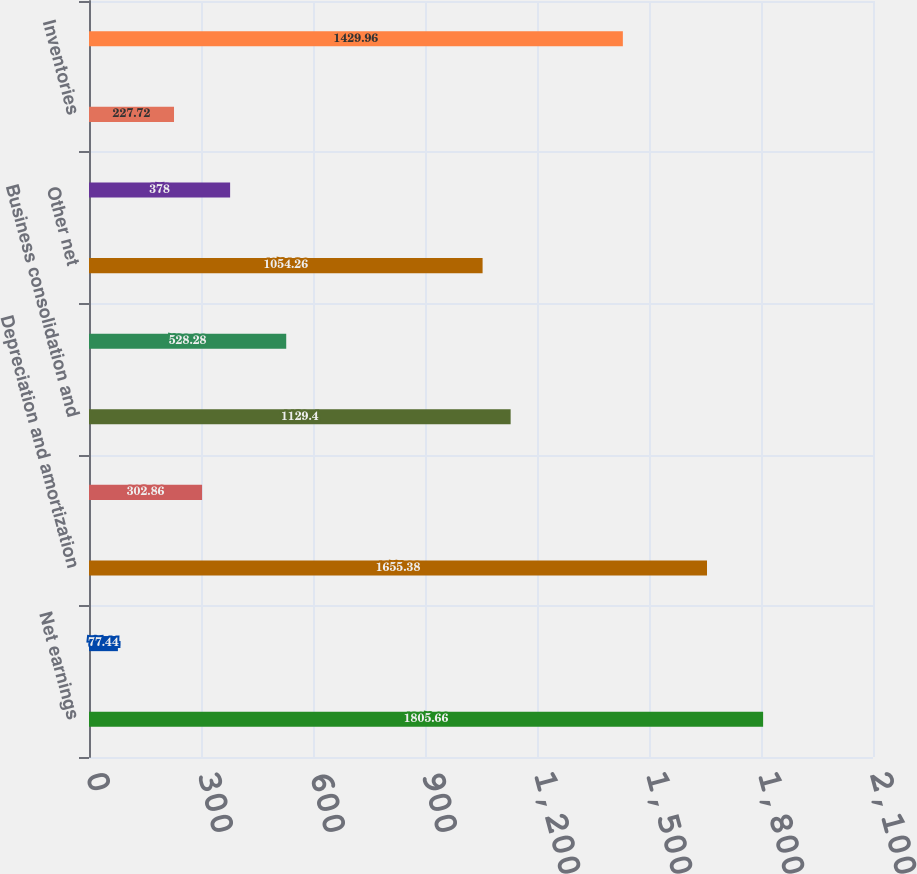<chart> <loc_0><loc_0><loc_500><loc_500><bar_chart><fcel>Net earnings<fcel>Discontinued operations net of<fcel>Depreciation and amortization<fcel>Equity earnings and gains<fcel>Business consolidation and<fcel>Deferred taxes<fcel>Other net<fcel>Receivables<fcel>Inventories<fcel>Other current assets<nl><fcel>1805.66<fcel>77.44<fcel>1655.38<fcel>302.86<fcel>1129.4<fcel>528.28<fcel>1054.26<fcel>378<fcel>227.72<fcel>1429.96<nl></chart> 